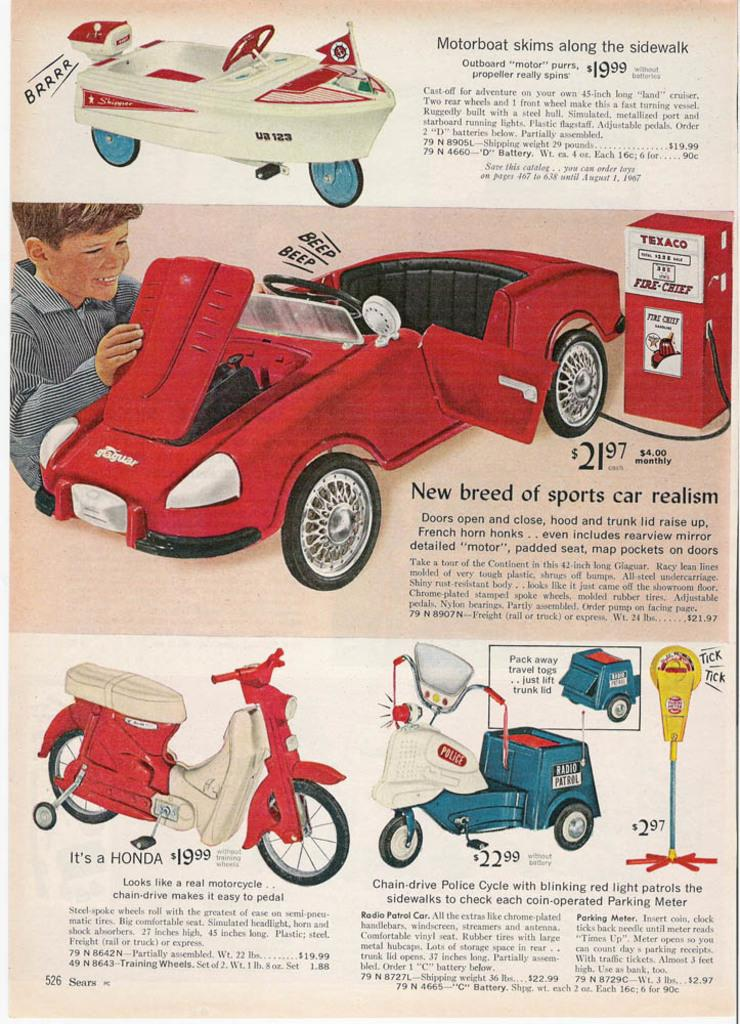What is the main subject of the paper in the image? The paper contains drawings of vehicles. Are there any other drawings on the paper besides vehicles? Yes, there are other things drawn on the paper. Can you describe the writing on the paper? There is writing on the paper. What type of ring can be seen on the parent's finger in the image? There is no parent or ring present in the image; it only features a paper with drawings and writing. Is there a drum visible in the image? There is no drum present in the image; it only features a paper with drawings and writing. 